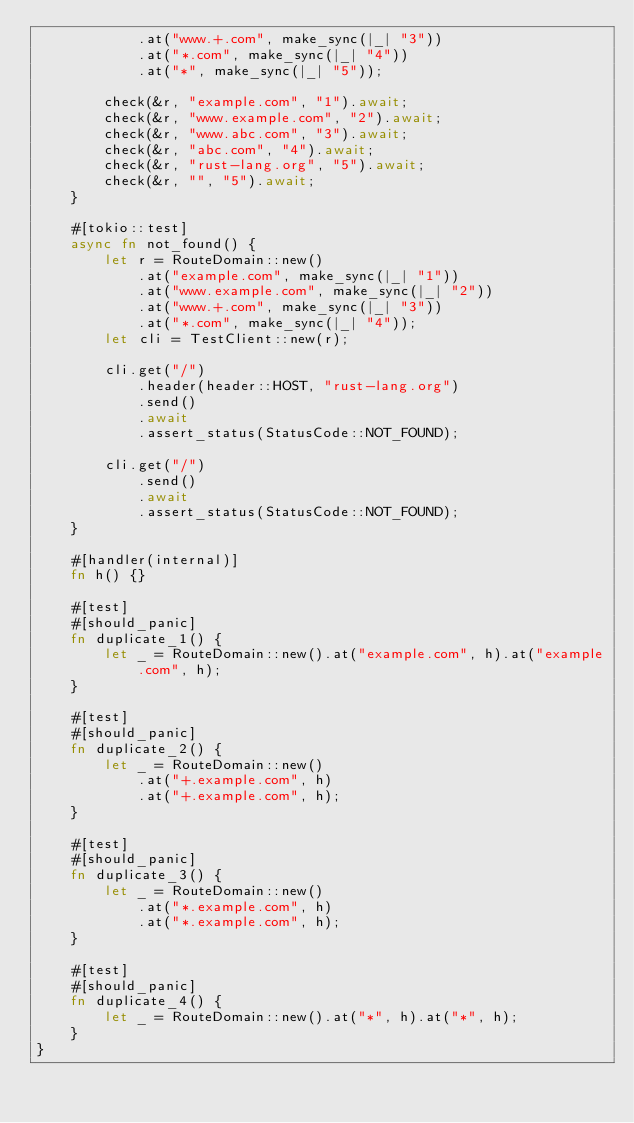<code> <loc_0><loc_0><loc_500><loc_500><_Rust_>            .at("www.+.com", make_sync(|_| "3"))
            .at("*.com", make_sync(|_| "4"))
            .at("*", make_sync(|_| "5"));

        check(&r, "example.com", "1").await;
        check(&r, "www.example.com", "2").await;
        check(&r, "www.abc.com", "3").await;
        check(&r, "abc.com", "4").await;
        check(&r, "rust-lang.org", "5").await;
        check(&r, "", "5").await;
    }

    #[tokio::test]
    async fn not_found() {
        let r = RouteDomain::new()
            .at("example.com", make_sync(|_| "1"))
            .at("www.example.com", make_sync(|_| "2"))
            .at("www.+.com", make_sync(|_| "3"))
            .at("*.com", make_sync(|_| "4"));
        let cli = TestClient::new(r);

        cli.get("/")
            .header(header::HOST, "rust-lang.org")
            .send()
            .await
            .assert_status(StatusCode::NOT_FOUND);

        cli.get("/")
            .send()
            .await
            .assert_status(StatusCode::NOT_FOUND);
    }

    #[handler(internal)]
    fn h() {}

    #[test]
    #[should_panic]
    fn duplicate_1() {
        let _ = RouteDomain::new().at("example.com", h).at("example.com", h);
    }

    #[test]
    #[should_panic]
    fn duplicate_2() {
        let _ = RouteDomain::new()
            .at("+.example.com", h)
            .at("+.example.com", h);
    }

    #[test]
    #[should_panic]
    fn duplicate_3() {
        let _ = RouteDomain::new()
            .at("*.example.com", h)
            .at("*.example.com", h);
    }

    #[test]
    #[should_panic]
    fn duplicate_4() {
        let _ = RouteDomain::new().at("*", h).at("*", h);
    }
}
</code> 